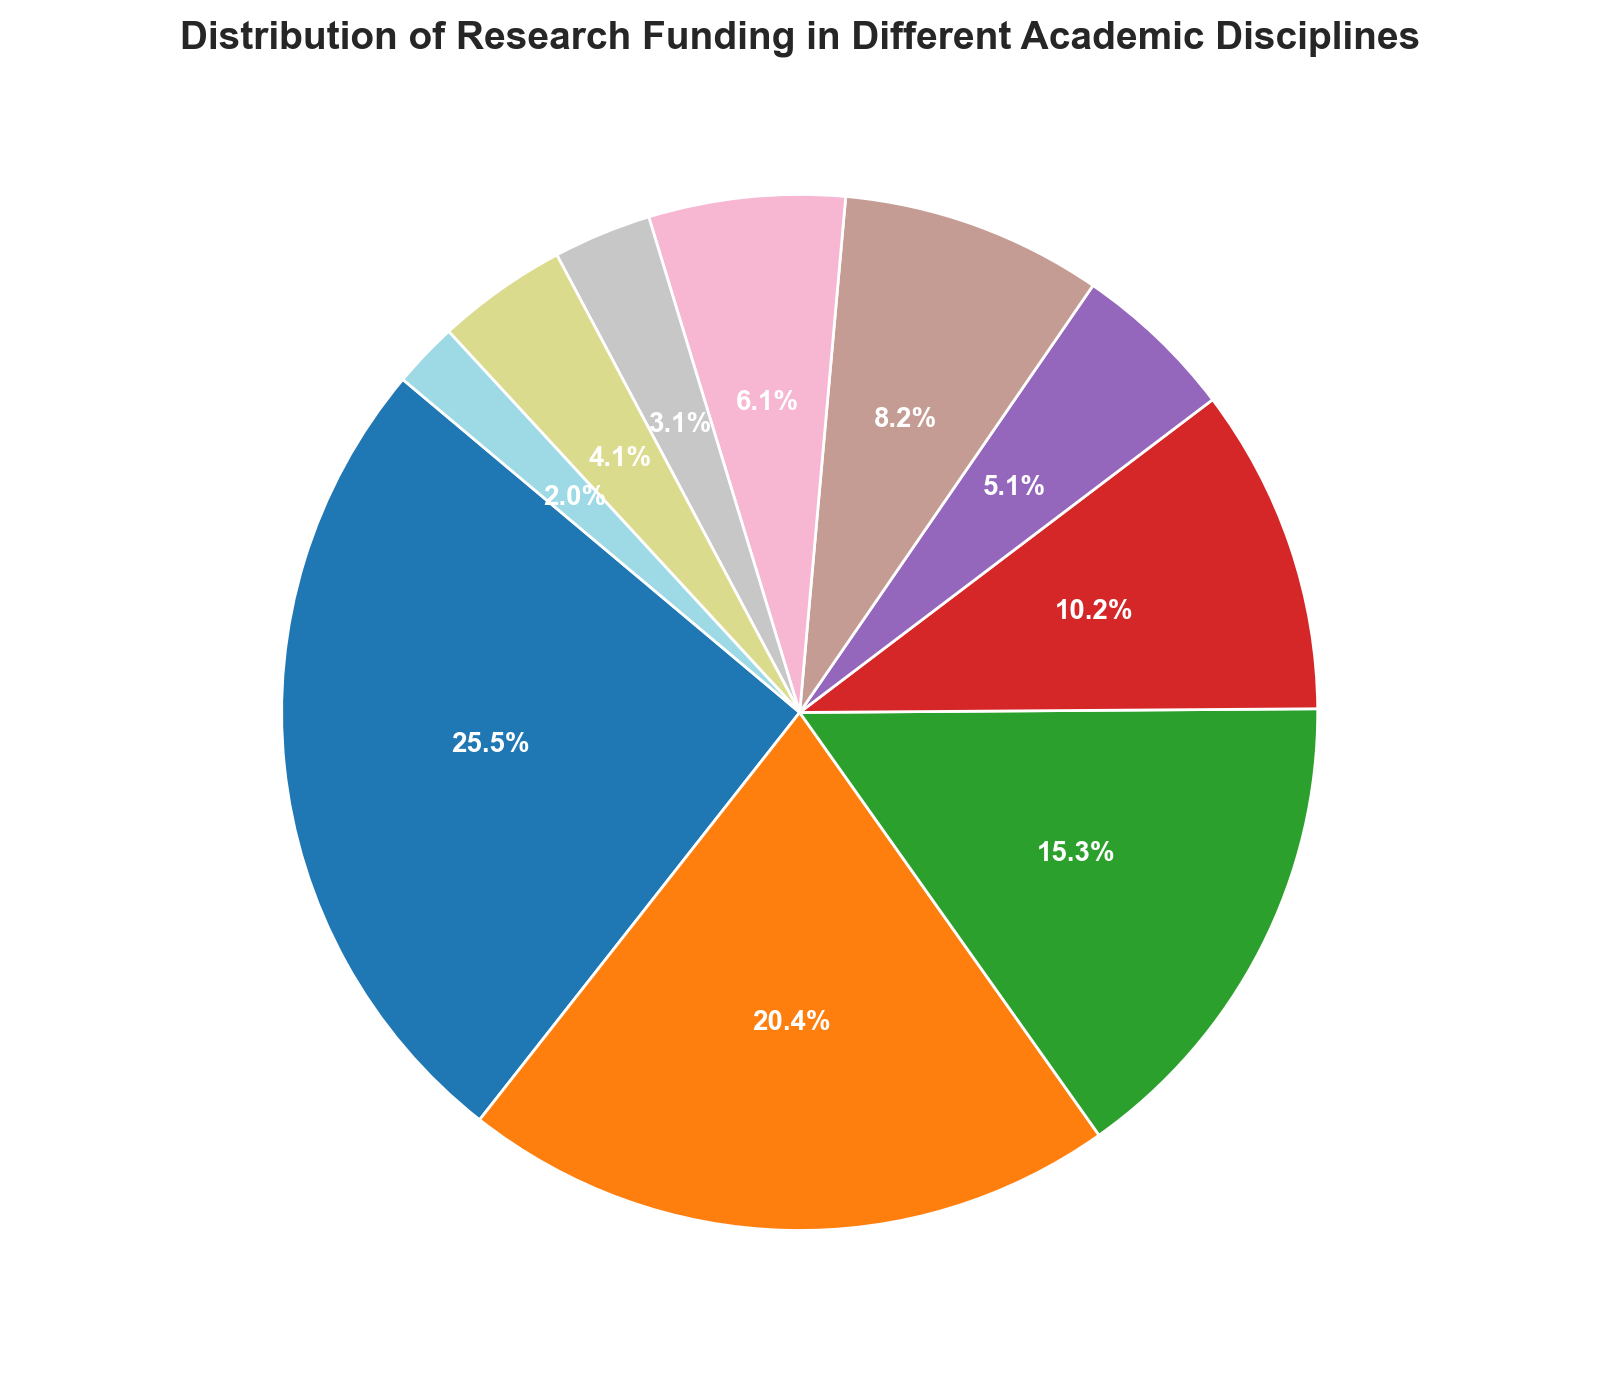Which discipline receives the highest percentage of research funding? The discipline with the largest segment in the pie chart represents the highest percentage of research funding. The Life Sciences segment appears to be the largest.
Answer: Life Sciences Which discipline receives the least funding? The discipline with the smallest segment in the pie chart represents the least funding. The Arts segment appears to be the smallest.
Answer: Arts Is the funding for Computer Science greater than the funding for Environmental Sciences? Compare the sizes of the segments for Computer Science and Environmental Sciences. The segment for Computer Science is larger than that of Environmental Sciences.
Answer: Yes What is the combined funding percentage for Physical Sciences and Engineering? Sum the individual percentages of Physical Sciences and Engineering: Physical Sciences is 15.0%, and Engineering is 20.0%. Therefore, the combined percentage is 15.0% + 20.0%.
Answer: 35.0% Are the Life Sciences funded more than Social Sciences and Mathematics combined? Compare the percentage of funding for Life Sciences with the sum of the percentages for Social Sciences and Mathematics: Life Sciences is 25.0%, while Social Sciences (10.0%) and Mathematics (5.0%) combined is 15.0%. Therefore, 25.0% is greater than 15.0%.
Answer: Yes What percentage of the funding is allocated to disciplines that receive less than $10,000,000 individually? Identify the disciplines that receive less than $10,000,000 individually (Mathematics, Humanities, Education, Arts) and sum their percentages: Mathematics (5.0%), Humanities (3.0%), Education (4.0%), and Arts (2.0%). The total is 5.0% + 3.0% + 4.0% + 2.0%.
Answer: 14.0% Which color represents the discipline with the second-highest funding? Identify the discipline with the second-highest funding (Engineering) in the pie chart and note its color (typically, this is visually checked). The corresponding segment for Engineering should be identified.
Answer: (Appropriate color from visual check, e.g., "blue") How does the funding for Humanities compare to Education? Compare the sizes of the segments for Humanities and Education by their percentages: Humanities is 3.0%, and Education is 4.0%. So, the funding for Education is higher than for Humanities.
Answer: Education What is the difference in funding percentage between Social Sciences and Physical Sciences? Calculate the difference in their percentages: Physical Sciences (15.0%) and Social Sciences (10.0%). The difference is 15.0% - 10.0%.
Answer: 5.0% 